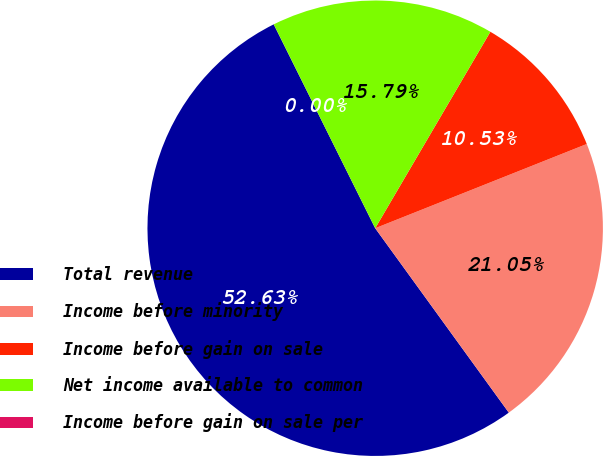Convert chart. <chart><loc_0><loc_0><loc_500><loc_500><pie_chart><fcel>Total revenue<fcel>Income before minority<fcel>Income before gain on sale<fcel>Net income available to common<fcel>Income before gain on sale per<nl><fcel>52.63%<fcel>21.05%<fcel>10.53%<fcel>15.79%<fcel>0.0%<nl></chart> 